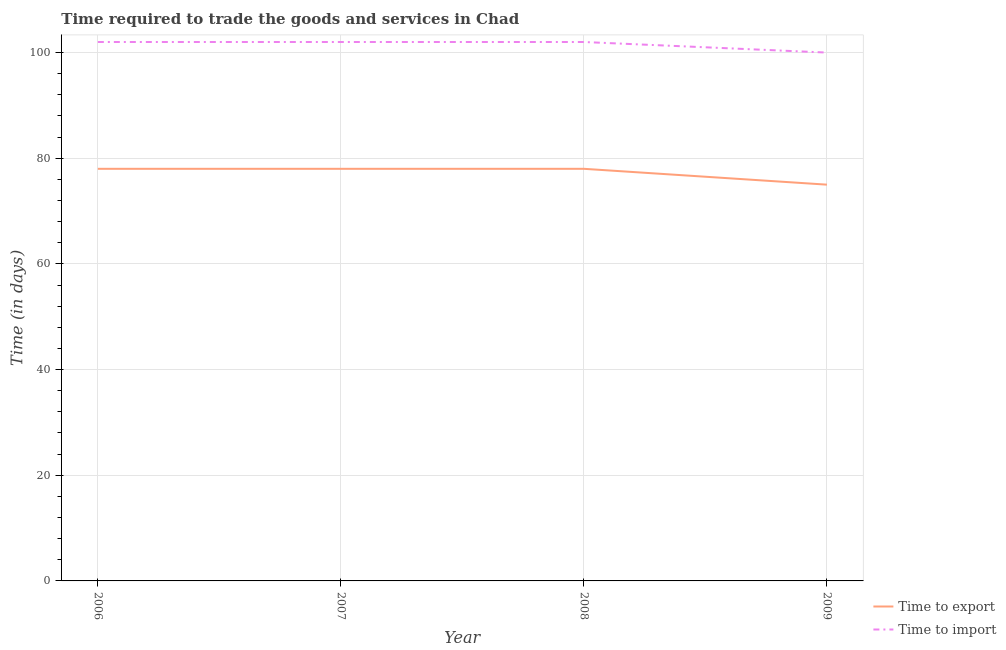Does the line corresponding to time to import intersect with the line corresponding to time to export?
Give a very brief answer. No. What is the time to export in 2007?
Your answer should be compact. 78. Across all years, what is the maximum time to export?
Provide a short and direct response. 78. Across all years, what is the minimum time to export?
Offer a terse response. 75. In which year was the time to import maximum?
Keep it short and to the point. 2006. In which year was the time to export minimum?
Keep it short and to the point. 2009. What is the total time to import in the graph?
Provide a short and direct response. 406. What is the difference between the time to export in 2008 and that in 2009?
Your answer should be very brief. 3. What is the difference between the time to export in 2007 and the time to import in 2009?
Offer a terse response. -22. What is the average time to export per year?
Your answer should be compact. 77.25. In the year 2006, what is the difference between the time to export and time to import?
Offer a very short reply. -24. In how many years, is the time to export greater than 92 days?
Give a very brief answer. 0. What is the ratio of the time to import in 2007 to that in 2008?
Provide a short and direct response. 1. What is the difference between the highest and the second highest time to import?
Offer a very short reply. 0. What is the difference between the highest and the lowest time to import?
Provide a succinct answer. 2. Is the sum of the time to import in 2006 and 2009 greater than the maximum time to export across all years?
Offer a terse response. Yes. Is the time to export strictly greater than the time to import over the years?
Provide a short and direct response. No. How many years are there in the graph?
Make the answer very short. 4. Does the graph contain any zero values?
Provide a short and direct response. No. How many legend labels are there?
Provide a succinct answer. 2. How are the legend labels stacked?
Offer a very short reply. Vertical. What is the title of the graph?
Offer a very short reply. Time required to trade the goods and services in Chad. What is the label or title of the X-axis?
Your answer should be compact. Year. What is the label or title of the Y-axis?
Provide a succinct answer. Time (in days). What is the Time (in days) in Time to export in 2006?
Your response must be concise. 78. What is the Time (in days) in Time to import in 2006?
Offer a very short reply. 102. What is the Time (in days) of Time to export in 2007?
Your answer should be very brief. 78. What is the Time (in days) of Time to import in 2007?
Keep it short and to the point. 102. What is the Time (in days) in Time to export in 2008?
Your answer should be compact. 78. What is the Time (in days) in Time to import in 2008?
Keep it short and to the point. 102. What is the Time (in days) in Time to export in 2009?
Provide a succinct answer. 75. What is the Time (in days) in Time to import in 2009?
Keep it short and to the point. 100. Across all years, what is the maximum Time (in days) of Time to export?
Your response must be concise. 78. Across all years, what is the maximum Time (in days) in Time to import?
Provide a succinct answer. 102. Across all years, what is the minimum Time (in days) of Time to export?
Provide a short and direct response. 75. What is the total Time (in days) of Time to export in the graph?
Your answer should be very brief. 309. What is the total Time (in days) of Time to import in the graph?
Provide a succinct answer. 406. What is the difference between the Time (in days) of Time to export in 2006 and that in 2008?
Keep it short and to the point. 0. What is the difference between the Time (in days) in Time to export in 2006 and that in 2009?
Give a very brief answer. 3. What is the difference between the Time (in days) of Time to export in 2007 and that in 2008?
Offer a very short reply. 0. What is the difference between the Time (in days) of Time to import in 2007 and that in 2008?
Ensure brevity in your answer.  0. What is the difference between the Time (in days) of Time to import in 2007 and that in 2009?
Provide a succinct answer. 2. What is the difference between the Time (in days) in Time to import in 2008 and that in 2009?
Make the answer very short. 2. What is the difference between the Time (in days) in Time to export in 2006 and the Time (in days) in Time to import in 2007?
Provide a succinct answer. -24. What is the difference between the Time (in days) of Time to export in 2006 and the Time (in days) of Time to import in 2009?
Your answer should be compact. -22. What is the difference between the Time (in days) of Time to export in 2007 and the Time (in days) of Time to import in 2009?
Your answer should be very brief. -22. What is the average Time (in days) in Time to export per year?
Keep it short and to the point. 77.25. What is the average Time (in days) of Time to import per year?
Your answer should be compact. 101.5. In the year 2007, what is the difference between the Time (in days) in Time to export and Time (in days) in Time to import?
Make the answer very short. -24. In the year 2009, what is the difference between the Time (in days) in Time to export and Time (in days) in Time to import?
Provide a succinct answer. -25. What is the ratio of the Time (in days) in Time to import in 2006 to that in 2007?
Provide a succinct answer. 1. What is the ratio of the Time (in days) in Time to export in 2006 to that in 2008?
Offer a very short reply. 1. What is the ratio of the Time (in days) of Time to import in 2006 to that in 2008?
Ensure brevity in your answer.  1. What is the ratio of the Time (in days) in Time to export in 2006 to that in 2009?
Your answer should be very brief. 1.04. What is the ratio of the Time (in days) in Time to import in 2006 to that in 2009?
Provide a short and direct response. 1.02. What is the ratio of the Time (in days) of Time to export in 2007 to that in 2008?
Your answer should be very brief. 1. What is the ratio of the Time (in days) in Time to export in 2007 to that in 2009?
Your answer should be compact. 1.04. What is the ratio of the Time (in days) of Time to import in 2008 to that in 2009?
Provide a short and direct response. 1.02. What is the difference between the highest and the second highest Time (in days) in Time to import?
Provide a succinct answer. 0. What is the difference between the highest and the lowest Time (in days) of Time to export?
Keep it short and to the point. 3. What is the difference between the highest and the lowest Time (in days) in Time to import?
Offer a terse response. 2. 